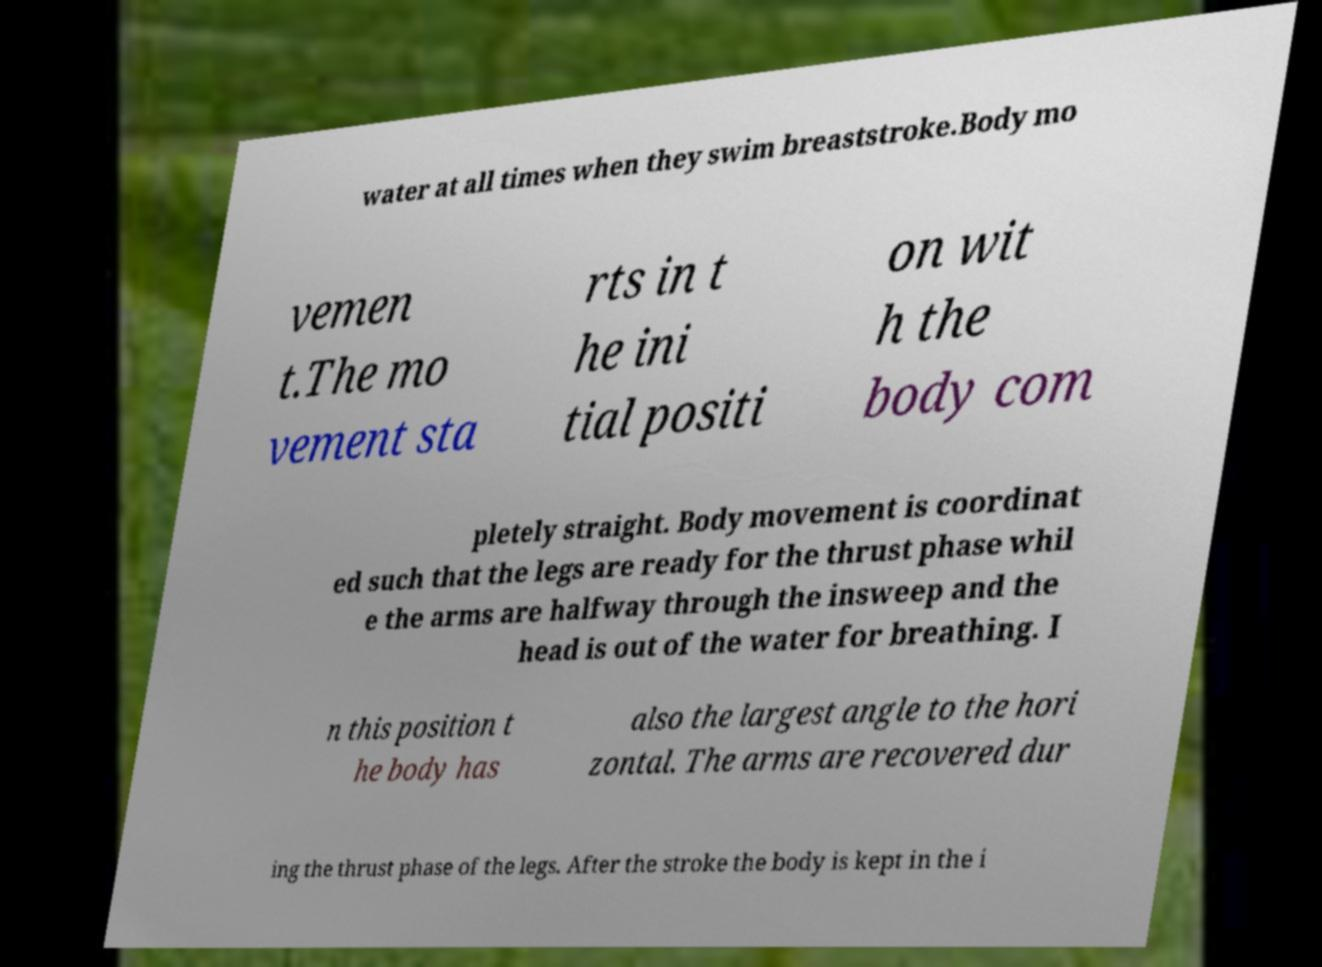I need the written content from this picture converted into text. Can you do that? water at all times when they swim breaststroke.Body mo vemen t.The mo vement sta rts in t he ini tial positi on wit h the body com pletely straight. Body movement is coordinat ed such that the legs are ready for the thrust phase whil e the arms are halfway through the insweep and the head is out of the water for breathing. I n this position t he body has also the largest angle to the hori zontal. The arms are recovered dur ing the thrust phase of the legs. After the stroke the body is kept in the i 